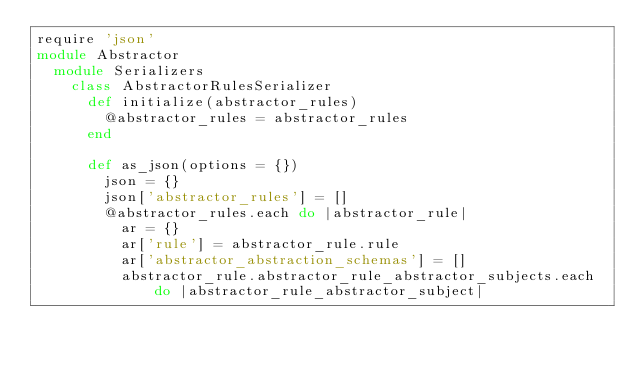Convert code to text. <code><loc_0><loc_0><loc_500><loc_500><_Ruby_>require 'json'
module Abstractor
  module Serializers
    class AbstractorRulesSerializer
      def initialize(abstractor_rules)
        @abstractor_rules = abstractor_rules
      end

      def as_json(options = {})
        json = {}
        json['abstractor_rules'] = []
        @abstractor_rules.each do |abstractor_rule|
          ar = {}
          ar['rule'] = abstractor_rule.rule
          ar['abstractor_abstraction_schemas'] = []
          abstractor_rule.abstractor_rule_abstractor_subjects.each do |abstractor_rule_abstractor_subject|</code> 